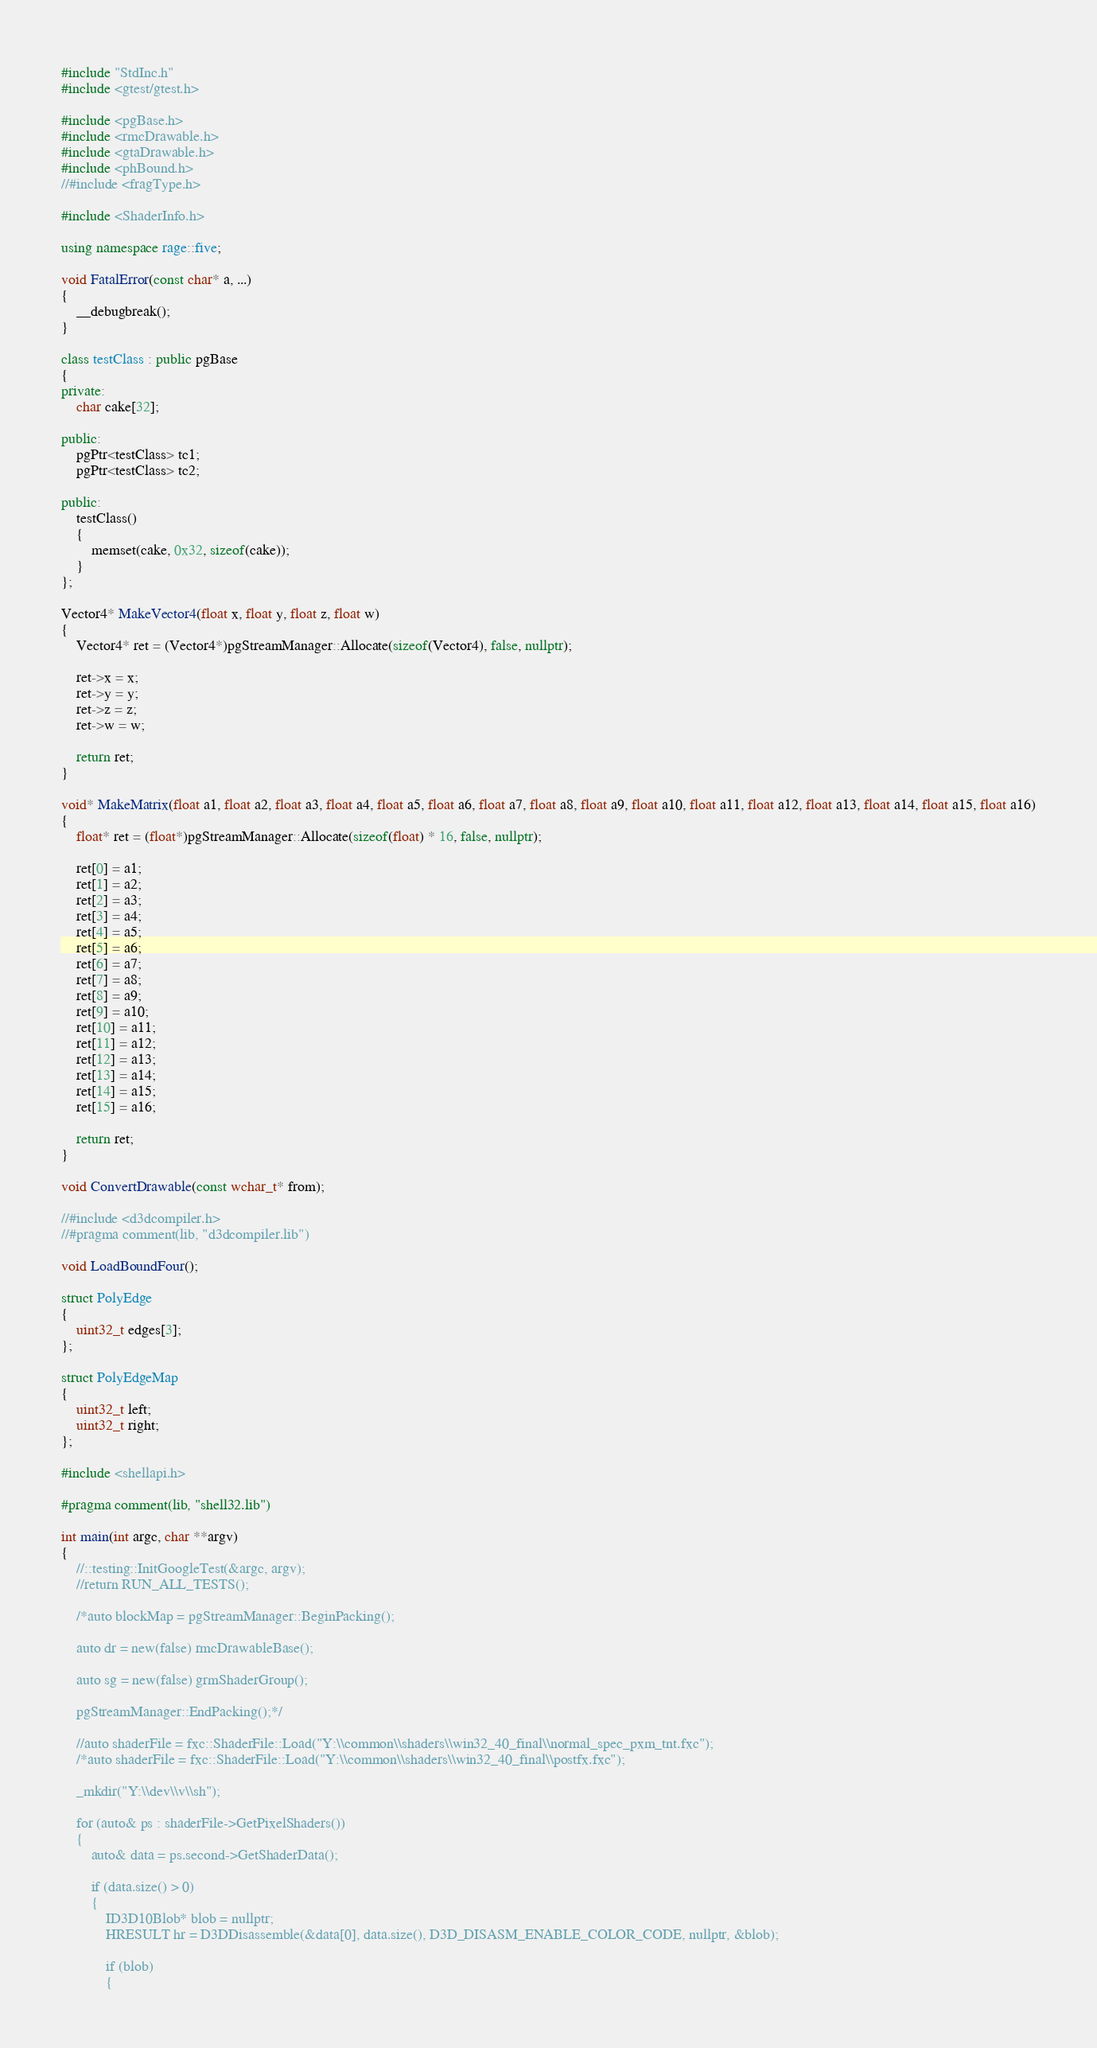Convert code to text. <code><loc_0><loc_0><loc_500><loc_500><_C++_>#include "StdInc.h"
#include <gtest/gtest.h>

#include <pgBase.h>
#include <rmcDrawable.h>
#include <gtaDrawable.h>
#include <phBound.h>
//#include <fragType.h>

#include <ShaderInfo.h>

using namespace rage::five;

void FatalError(const char* a, ...)
{
	__debugbreak();
}

class testClass : public pgBase
{
private:
	char cake[32];

public:
	pgPtr<testClass> tc1;
	pgPtr<testClass> tc2;

public:
	testClass()
	{
		memset(cake, 0x32, sizeof(cake));
	}
};

Vector4* MakeVector4(float x, float y, float z, float w)
{
	Vector4* ret = (Vector4*)pgStreamManager::Allocate(sizeof(Vector4), false, nullptr);

	ret->x = x;
	ret->y = y;
	ret->z = z;
	ret->w = w;

	return ret;
}

void* MakeMatrix(float a1, float a2, float a3, float a4, float a5, float a6, float a7, float a8, float a9, float a10, float a11, float a12, float a13, float a14, float a15, float a16)
{
	float* ret = (float*)pgStreamManager::Allocate(sizeof(float) * 16, false, nullptr);

	ret[0] = a1;
	ret[1] = a2;
	ret[2] = a3;
	ret[3] = a4;
	ret[4] = a5;
	ret[5] = a6;
	ret[6] = a7;
	ret[7] = a8;
	ret[8] = a9;
	ret[9] = a10;
	ret[10] = a11;
	ret[11] = a12;
	ret[12] = a13;
	ret[13] = a14;
	ret[14] = a15;
	ret[15] = a16;

	return ret;
}

void ConvertDrawable(const wchar_t* from);

//#include <d3dcompiler.h>
//#pragma comment(lib, "d3dcompiler.lib")

void LoadBoundFour();

struct PolyEdge
{
	uint32_t edges[3];
};

struct PolyEdgeMap
{
	uint32_t left;
	uint32_t right;
};

#include <shellapi.h>

#pragma comment(lib, "shell32.lib")

int main(int argc, char **argv)
{
	//::testing::InitGoogleTest(&argc, argv);
	//return RUN_ALL_TESTS();

	/*auto blockMap = pgStreamManager::BeginPacking();

	auto dr = new(false) rmcDrawableBase();

	auto sg = new(false) grmShaderGroup();
	
	pgStreamManager::EndPacking();*/

	//auto shaderFile = fxc::ShaderFile::Load("Y:\\common\\shaders\\win32_40_final\\normal_spec_pxm_tnt.fxc");
	/*auto shaderFile = fxc::ShaderFile::Load("Y:\\common\\shaders\\win32_40_final\\postfx.fxc");

	_mkdir("Y:\\dev\\v\\sh");

	for (auto& ps : shaderFile->GetPixelShaders())
	{
		auto& data = ps.second->GetShaderData();

		if (data.size() > 0)
		{
			ID3D10Blob* blob = nullptr;
			HRESULT hr = D3DDisassemble(&data[0], data.size(), D3D_DISASM_ENABLE_COLOR_CODE, nullptr, &blob);

			if (blob)
			{</code> 